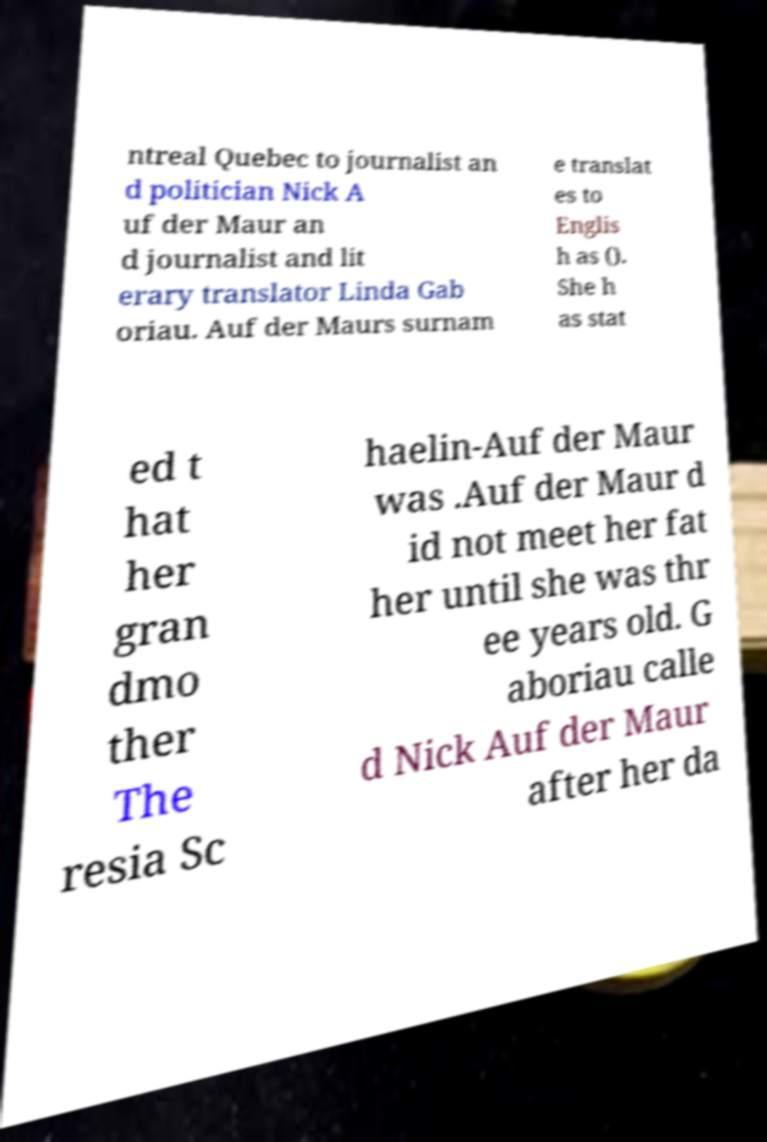Please identify and transcribe the text found in this image. ntreal Quebec to journalist an d politician Nick A uf der Maur an d journalist and lit erary translator Linda Gab oriau. Auf der Maurs surnam e translat es to Englis h as (). She h as stat ed t hat her gran dmo ther The resia Sc haelin-Auf der Maur was .Auf der Maur d id not meet her fat her until she was thr ee years old. G aboriau calle d Nick Auf der Maur after her da 